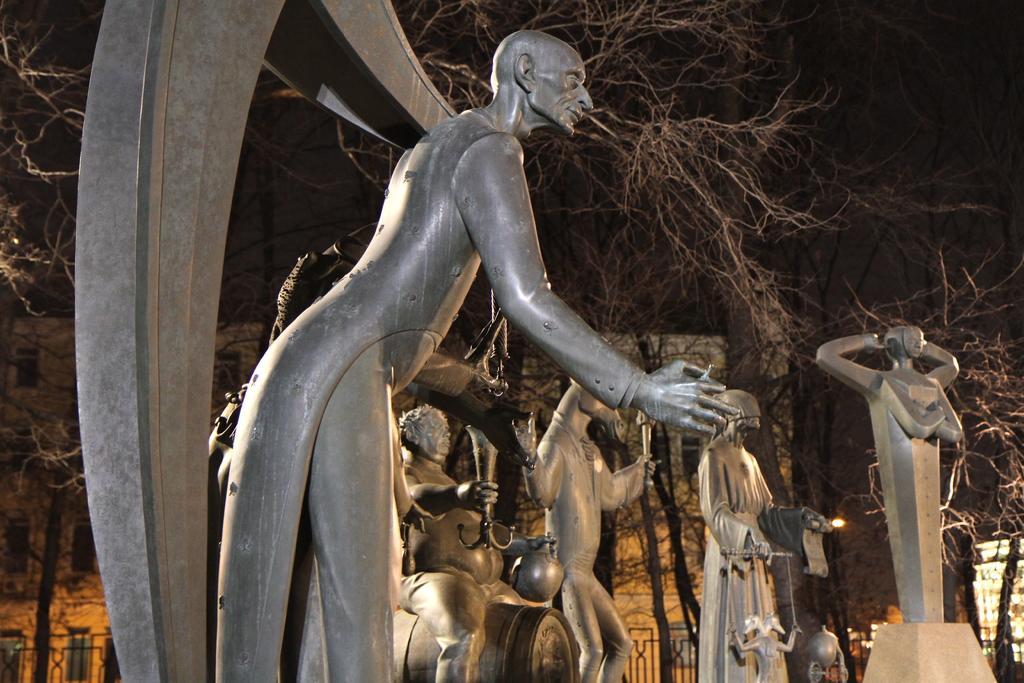In one or two sentences, can you explain what this image depicts? In the picture we can see some sculptures which are gray in color and behind it we can see some dried trees and building with windows and railing around it. 